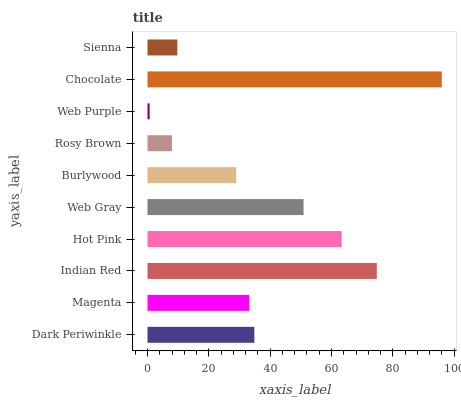Is Web Purple the minimum?
Answer yes or no. Yes. Is Chocolate the maximum?
Answer yes or no. Yes. Is Magenta the minimum?
Answer yes or no. No. Is Magenta the maximum?
Answer yes or no. No. Is Dark Periwinkle greater than Magenta?
Answer yes or no. Yes. Is Magenta less than Dark Periwinkle?
Answer yes or no. Yes. Is Magenta greater than Dark Periwinkle?
Answer yes or no. No. Is Dark Periwinkle less than Magenta?
Answer yes or no. No. Is Dark Periwinkle the high median?
Answer yes or no. Yes. Is Magenta the low median?
Answer yes or no. Yes. Is Web Purple the high median?
Answer yes or no. No. Is Burlywood the low median?
Answer yes or no. No. 